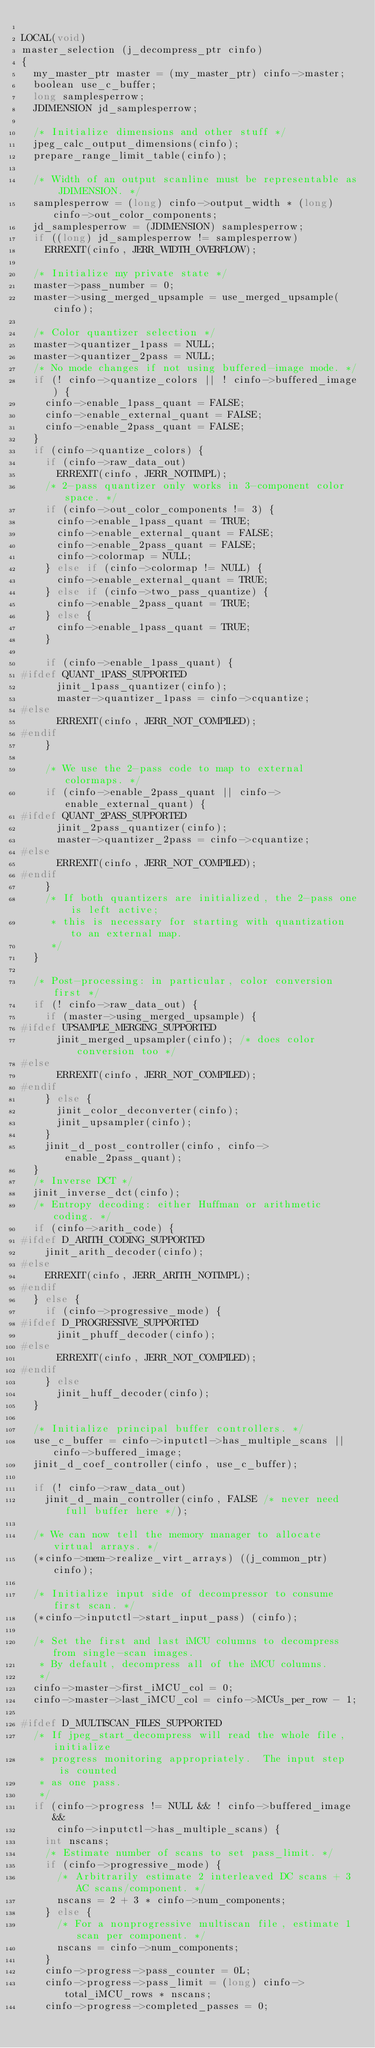Convert code to text. <code><loc_0><loc_0><loc_500><loc_500><_C_>
LOCAL(void)
master_selection (j_decompress_ptr cinfo)
{
  my_master_ptr master = (my_master_ptr) cinfo->master;
  boolean use_c_buffer;
  long samplesperrow;
  JDIMENSION jd_samplesperrow;

  /* Initialize dimensions and other stuff */
  jpeg_calc_output_dimensions(cinfo);
  prepare_range_limit_table(cinfo);

  /* Width of an output scanline must be representable as JDIMENSION. */
  samplesperrow = (long) cinfo->output_width * (long) cinfo->out_color_components;
  jd_samplesperrow = (JDIMENSION) samplesperrow;
  if ((long) jd_samplesperrow != samplesperrow)
    ERREXIT(cinfo, JERR_WIDTH_OVERFLOW);

  /* Initialize my private state */
  master->pass_number = 0;
  master->using_merged_upsample = use_merged_upsample(cinfo);

  /* Color quantizer selection */
  master->quantizer_1pass = NULL;
  master->quantizer_2pass = NULL;
  /* No mode changes if not using buffered-image mode. */
  if (! cinfo->quantize_colors || ! cinfo->buffered_image) {
    cinfo->enable_1pass_quant = FALSE;
    cinfo->enable_external_quant = FALSE;
    cinfo->enable_2pass_quant = FALSE;
  }
  if (cinfo->quantize_colors) {
    if (cinfo->raw_data_out)
      ERREXIT(cinfo, JERR_NOTIMPL);
    /* 2-pass quantizer only works in 3-component color space. */
    if (cinfo->out_color_components != 3) {
      cinfo->enable_1pass_quant = TRUE;
      cinfo->enable_external_quant = FALSE;
      cinfo->enable_2pass_quant = FALSE;
      cinfo->colormap = NULL;
    } else if (cinfo->colormap != NULL) {
      cinfo->enable_external_quant = TRUE;
    } else if (cinfo->two_pass_quantize) {
      cinfo->enable_2pass_quant = TRUE;
    } else {
      cinfo->enable_1pass_quant = TRUE;
    }

    if (cinfo->enable_1pass_quant) {
#ifdef QUANT_1PASS_SUPPORTED
      jinit_1pass_quantizer(cinfo);
      master->quantizer_1pass = cinfo->cquantize;
#else
      ERREXIT(cinfo, JERR_NOT_COMPILED);
#endif
    }

    /* We use the 2-pass code to map to external colormaps. */
    if (cinfo->enable_2pass_quant || cinfo->enable_external_quant) {
#ifdef QUANT_2PASS_SUPPORTED
      jinit_2pass_quantizer(cinfo);
      master->quantizer_2pass = cinfo->cquantize;
#else
      ERREXIT(cinfo, JERR_NOT_COMPILED);
#endif
    }
    /* If both quantizers are initialized, the 2-pass one is left active;
     * this is necessary for starting with quantization to an external map.
     */
  }

  /* Post-processing: in particular, color conversion first */
  if (! cinfo->raw_data_out) {
    if (master->using_merged_upsample) {
#ifdef UPSAMPLE_MERGING_SUPPORTED
      jinit_merged_upsampler(cinfo); /* does color conversion too */
#else
      ERREXIT(cinfo, JERR_NOT_COMPILED);
#endif
    } else {
      jinit_color_deconverter(cinfo);
      jinit_upsampler(cinfo);
    }
    jinit_d_post_controller(cinfo, cinfo->enable_2pass_quant);
  }
  /* Inverse DCT */
  jinit_inverse_dct(cinfo);
  /* Entropy decoding: either Huffman or arithmetic coding. */
  if (cinfo->arith_code) {
#ifdef D_ARITH_CODING_SUPPORTED
    jinit_arith_decoder(cinfo);
#else
    ERREXIT(cinfo, JERR_ARITH_NOTIMPL);
#endif
  } else {
    if (cinfo->progressive_mode) {
#ifdef D_PROGRESSIVE_SUPPORTED
      jinit_phuff_decoder(cinfo);
#else
      ERREXIT(cinfo, JERR_NOT_COMPILED);
#endif
    } else
      jinit_huff_decoder(cinfo);
  }

  /* Initialize principal buffer controllers. */
  use_c_buffer = cinfo->inputctl->has_multiple_scans || cinfo->buffered_image;
  jinit_d_coef_controller(cinfo, use_c_buffer);

  if (! cinfo->raw_data_out)
    jinit_d_main_controller(cinfo, FALSE /* never need full buffer here */);

  /* We can now tell the memory manager to allocate virtual arrays. */
  (*cinfo->mem->realize_virt_arrays) ((j_common_ptr) cinfo);

  /* Initialize input side of decompressor to consume first scan. */
  (*cinfo->inputctl->start_input_pass) (cinfo);

  /* Set the first and last iMCU columns to decompress from single-scan images.
   * By default, decompress all of the iMCU columns.
   */
  cinfo->master->first_iMCU_col = 0;
  cinfo->master->last_iMCU_col = cinfo->MCUs_per_row - 1;

#ifdef D_MULTISCAN_FILES_SUPPORTED
  /* If jpeg_start_decompress will read the whole file, initialize
   * progress monitoring appropriately.  The input step is counted
   * as one pass.
   */
  if (cinfo->progress != NULL && ! cinfo->buffered_image &&
      cinfo->inputctl->has_multiple_scans) {
    int nscans;
    /* Estimate number of scans to set pass_limit. */
    if (cinfo->progressive_mode) {
      /* Arbitrarily estimate 2 interleaved DC scans + 3 AC scans/component. */
      nscans = 2 + 3 * cinfo->num_components;
    } else {
      /* For a nonprogressive multiscan file, estimate 1 scan per component. */
      nscans = cinfo->num_components;
    }
    cinfo->progress->pass_counter = 0L;
    cinfo->progress->pass_limit = (long) cinfo->total_iMCU_rows * nscans;
    cinfo->progress->completed_passes = 0;</code> 